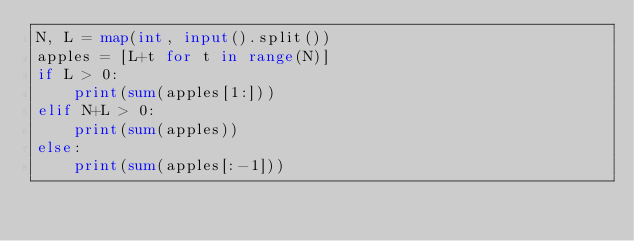<code> <loc_0><loc_0><loc_500><loc_500><_Python_>N, L = map(int, input().split())
apples = [L+t for t in range(N)]
if L > 0:
    print(sum(apples[1:]))
elif N+L > 0:
    print(sum(apples))
else:
    print(sum(apples[:-1]))
</code> 